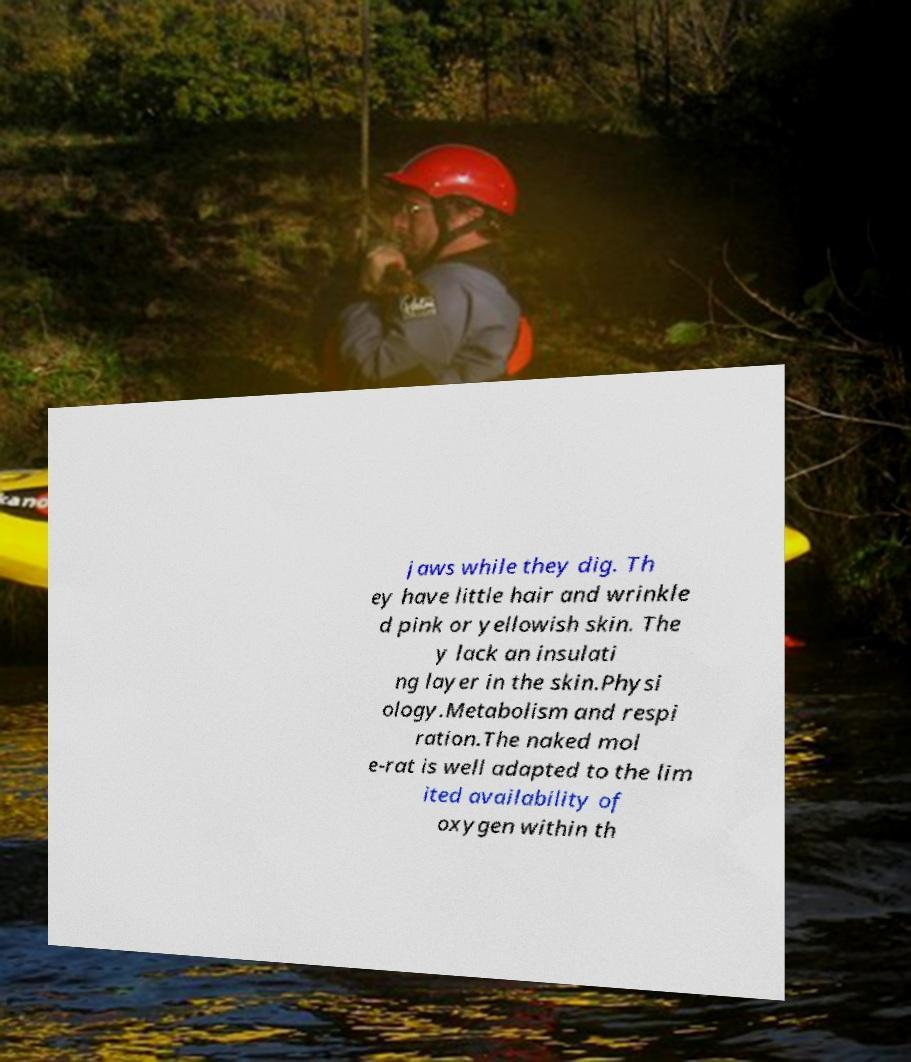I need the written content from this picture converted into text. Can you do that? jaws while they dig. Th ey have little hair and wrinkle d pink or yellowish skin. The y lack an insulati ng layer in the skin.Physi ology.Metabolism and respi ration.The naked mol e-rat is well adapted to the lim ited availability of oxygen within th 